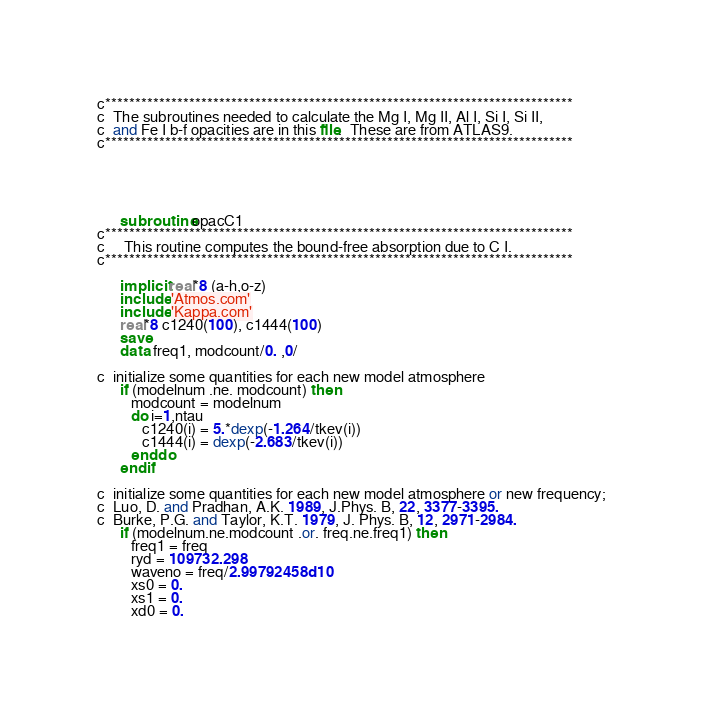Convert code to text. <code><loc_0><loc_0><loc_500><loc_500><_FORTRAN_>
c******************************************************************************
c  The subroutines needed to calculate the Mg I, Mg II, Al I, Si I, Si II,
c  and Fe I b-f opacities are in this file.  These are from ATLAS9.
c******************************************************************************





      subroutine opacC1
c******************************************************************************
c     This routine computes the bound-free absorption due to C I.
c******************************************************************************

      implicit real*8 (a-h,o-z)
      include 'Atmos.com'
      include 'Kappa.com'
      real*8 c1240(100), c1444(100)
      save
      data freq1, modcount/0. ,0/

c  initialize some quantities for each new model atmosphere
      if (modelnum .ne. modcount) then
         modcount = modelnum
         do i=1,ntau
            c1240(i) = 5.*dexp(-1.264/tkev(i))
            c1444(i) = dexp(-2.683/tkev(i))
         enddo
      endif

c  initialize some quantities for each new model atmosphere or new frequency;
c  Luo, D. and Pradhan, A.K. 1989, J.Phys. B, 22, 3377-3395.
c  Burke, P.G. and Taylor, K.T. 1979, J. Phys. B, 12, 2971-2984.
      if (modelnum.ne.modcount .or. freq.ne.freq1) then
         freq1 = freq
         ryd = 109732.298
         waveno = freq/2.99792458d10
         xs0 = 0.
         xs1 = 0.
         xd0 = 0.</code> 